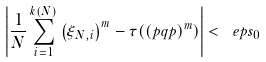Convert formula to latex. <formula><loc_0><loc_0><loc_500><loc_500>\left | \frac { 1 } { N } \sum _ { i = 1 } ^ { k ( N ) } \left ( \xi _ { N , i } \right ) ^ { m } - \tau ( ( p q p ) ^ { m } ) \right | < \ e p s _ { 0 }</formula> 